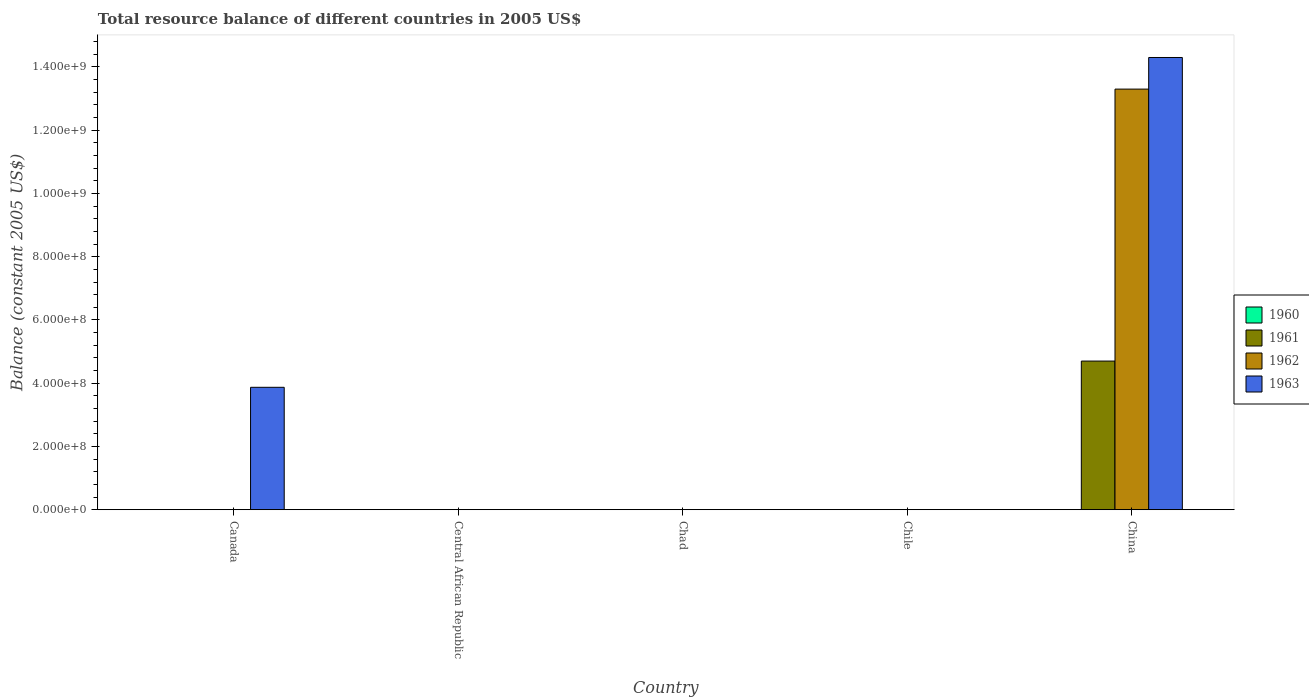Are the number of bars per tick equal to the number of legend labels?
Keep it short and to the point. No. Are the number of bars on each tick of the X-axis equal?
Your answer should be compact. No. How many bars are there on the 4th tick from the left?
Offer a terse response. 0. How many bars are there on the 4th tick from the right?
Your response must be concise. 0. What is the label of the 2nd group of bars from the left?
Offer a terse response. Central African Republic. In how many cases, is the number of bars for a given country not equal to the number of legend labels?
Offer a very short reply. 5. What is the total resource balance in 1962 in China?
Your answer should be compact. 1.33e+09. Across all countries, what is the maximum total resource balance in 1961?
Your answer should be very brief. 4.70e+08. In which country was the total resource balance in 1962 maximum?
Offer a terse response. China. What is the total total resource balance in 1962 in the graph?
Offer a terse response. 1.33e+09. What is the difference between the total resource balance in 1963 in Canada and that in China?
Offer a very short reply. -1.04e+09. What is the average total resource balance in 1961 per country?
Provide a succinct answer. 9.40e+07. What is the difference between the total resource balance of/in 1962 and total resource balance of/in 1961 in China?
Make the answer very short. 8.60e+08. What is the ratio of the total resource balance in 1963 in Canada to that in China?
Offer a very short reply. 0.27. What is the difference between the highest and the lowest total resource balance in 1962?
Make the answer very short. 1.33e+09. How many bars are there?
Ensure brevity in your answer.  4. How many countries are there in the graph?
Your response must be concise. 5. What is the difference between two consecutive major ticks on the Y-axis?
Your answer should be compact. 2.00e+08. Are the values on the major ticks of Y-axis written in scientific E-notation?
Keep it short and to the point. Yes. Does the graph contain grids?
Offer a very short reply. No. How many legend labels are there?
Provide a succinct answer. 4. How are the legend labels stacked?
Your response must be concise. Vertical. What is the title of the graph?
Your response must be concise. Total resource balance of different countries in 2005 US$. What is the label or title of the Y-axis?
Offer a terse response. Balance (constant 2005 US$). What is the Balance (constant 2005 US$) in 1961 in Canada?
Your answer should be compact. 0. What is the Balance (constant 2005 US$) of 1963 in Canada?
Give a very brief answer. 3.87e+08. What is the Balance (constant 2005 US$) in 1960 in Central African Republic?
Provide a succinct answer. 0. What is the Balance (constant 2005 US$) in 1961 in Central African Republic?
Your response must be concise. 0. What is the Balance (constant 2005 US$) in 1960 in Chile?
Offer a terse response. 0. What is the Balance (constant 2005 US$) of 1961 in China?
Your response must be concise. 4.70e+08. What is the Balance (constant 2005 US$) in 1962 in China?
Provide a short and direct response. 1.33e+09. What is the Balance (constant 2005 US$) in 1963 in China?
Keep it short and to the point. 1.43e+09. Across all countries, what is the maximum Balance (constant 2005 US$) in 1961?
Your response must be concise. 4.70e+08. Across all countries, what is the maximum Balance (constant 2005 US$) of 1962?
Offer a terse response. 1.33e+09. Across all countries, what is the maximum Balance (constant 2005 US$) in 1963?
Give a very brief answer. 1.43e+09. Across all countries, what is the minimum Balance (constant 2005 US$) of 1961?
Your response must be concise. 0. Across all countries, what is the minimum Balance (constant 2005 US$) of 1963?
Keep it short and to the point. 0. What is the total Balance (constant 2005 US$) in 1960 in the graph?
Provide a succinct answer. 0. What is the total Balance (constant 2005 US$) in 1961 in the graph?
Your response must be concise. 4.70e+08. What is the total Balance (constant 2005 US$) of 1962 in the graph?
Provide a succinct answer. 1.33e+09. What is the total Balance (constant 2005 US$) of 1963 in the graph?
Offer a very short reply. 1.82e+09. What is the difference between the Balance (constant 2005 US$) in 1963 in Canada and that in China?
Provide a short and direct response. -1.04e+09. What is the average Balance (constant 2005 US$) of 1960 per country?
Offer a very short reply. 0. What is the average Balance (constant 2005 US$) in 1961 per country?
Your answer should be very brief. 9.40e+07. What is the average Balance (constant 2005 US$) of 1962 per country?
Provide a succinct answer. 2.66e+08. What is the average Balance (constant 2005 US$) of 1963 per country?
Your response must be concise. 3.63e+08. What is the difference between the Balance (constant 2005 US$) of 1961 and Balance (constant 2005 US$) of 1962 in China?
Give a very brief answer. -8.60e+08. What is the difference between the Balance (constant 2005 US$) of 1961 and Balance (constant 2005 US$) of 1963 in China?
Your response must be concise. -9.60e+08. What is the difference between the Balance (constant 2005 US$) of 1962 and Balance (constant 2005 US$) of 1963 in China?
Keep it short and to the point. -1.00e+08. What is the ratio of the Balance (constant 2005 US$) in 1963 in Canada to that in China?
Offer a very short reply. 0.27. What is the difference between the highest and the lowest Balance (constant 2005 US$) of 1961?
Your response must be concise. 4.70e+08. What is the difference between the highest and the lowest Balance (constant 2005 US$) of 1962?
Your answer should be compact. 1.33e+09. What is the difference between the highest and the lowest Balance (constant 2005 US$) in 1963?
Your response must be concise. 1.43e+09. 